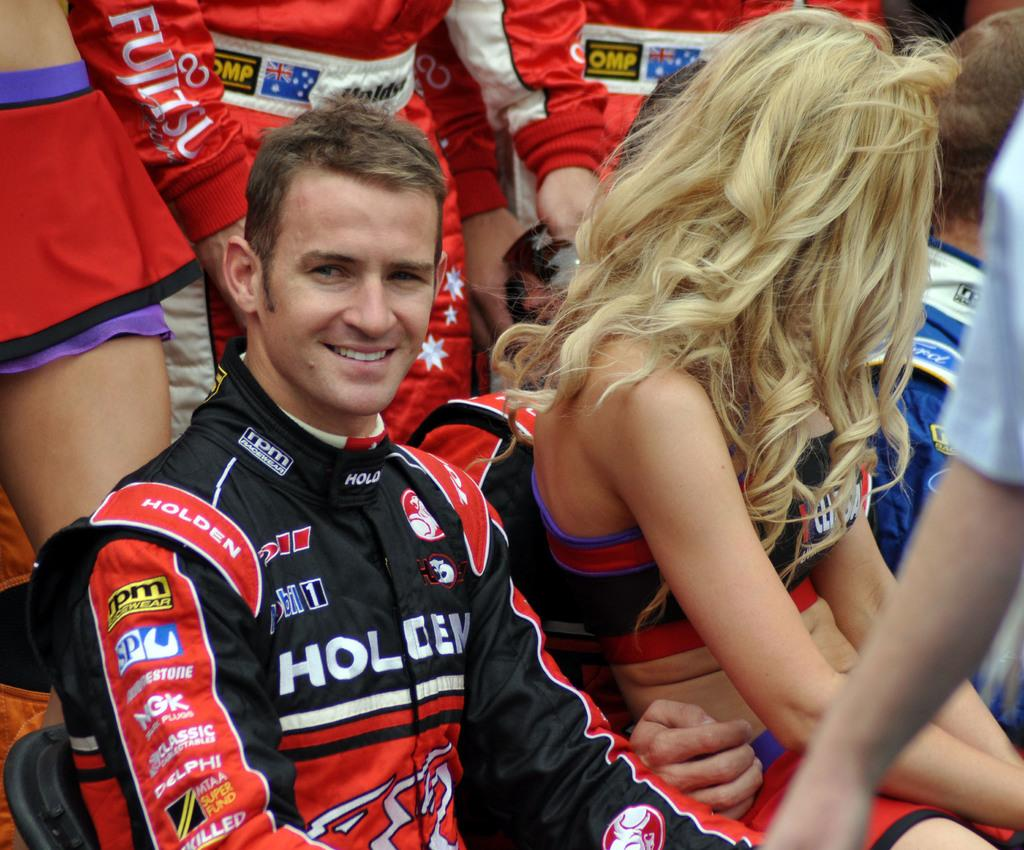<image>
Create a compact narrative representing the image presented. a smiling man wears a uniform with the letters HOL on it 